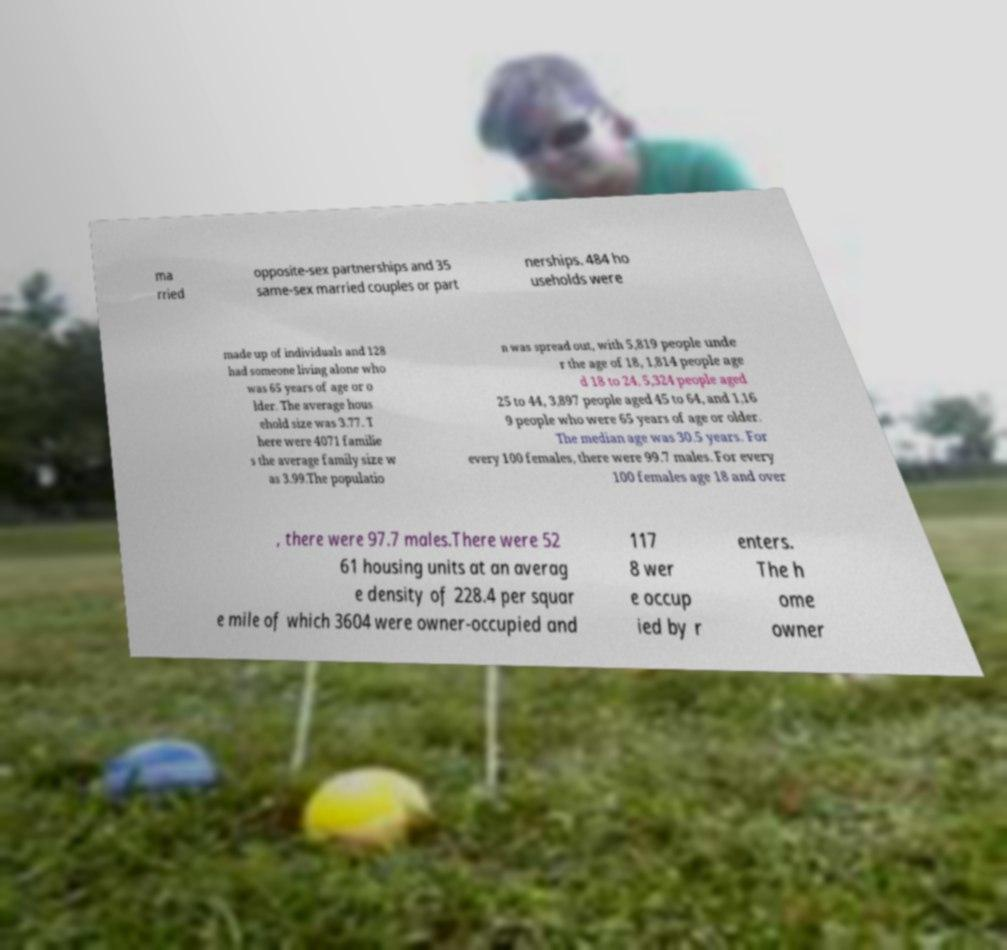There's text embedded in this image that I need extracted. Can you transcribe it verbatim? ma rried opposite-sex partnerships and 35 same-sex married couples or part nerships. 484 ho useholds were made up of individuals and 128 had someone living alone who was 65 years of age or o lder. The average hous ehold size was 3.77. T here were 4071 familie s the average family size w as 3.99.The populatio n was spread out, with 5,819 people unde r the age of 18, 1,814 people age d 18 to 24, 5,324 people aged 25 to 44, 3,897 people aged 45 to 64, and 1,16 9 people who were 65 years of age or older. The median age was 30.5 years. For every 100 females, there were 99.7 males. For every 100 females age 18 and over , there were 97.7 males.There were 52 61 housing units at an averag e density of 228.4 per squar e mile of which 3604 were owner-occupied and 117 8 wer e occup ied by r enters. The h ome owner 